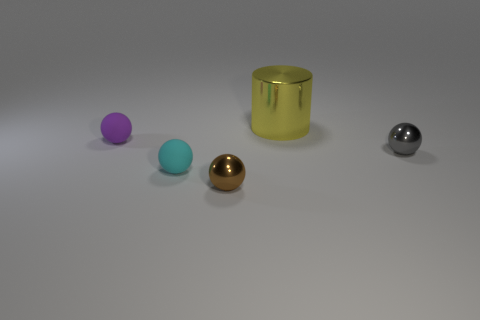Add 2 purple objects. How many objects exist? 7 Subtract all cylinders. How many objects are left? 4 Add 2 small purple things. How many small purple things exist? 3 Subtract 1 yellow cylinders. How many objects are left? 4 Subtract all yellow blocks. Subtract all cylinders. How many objects are left? 4 Add 2 metallic things. How many metallic things are left? 5 